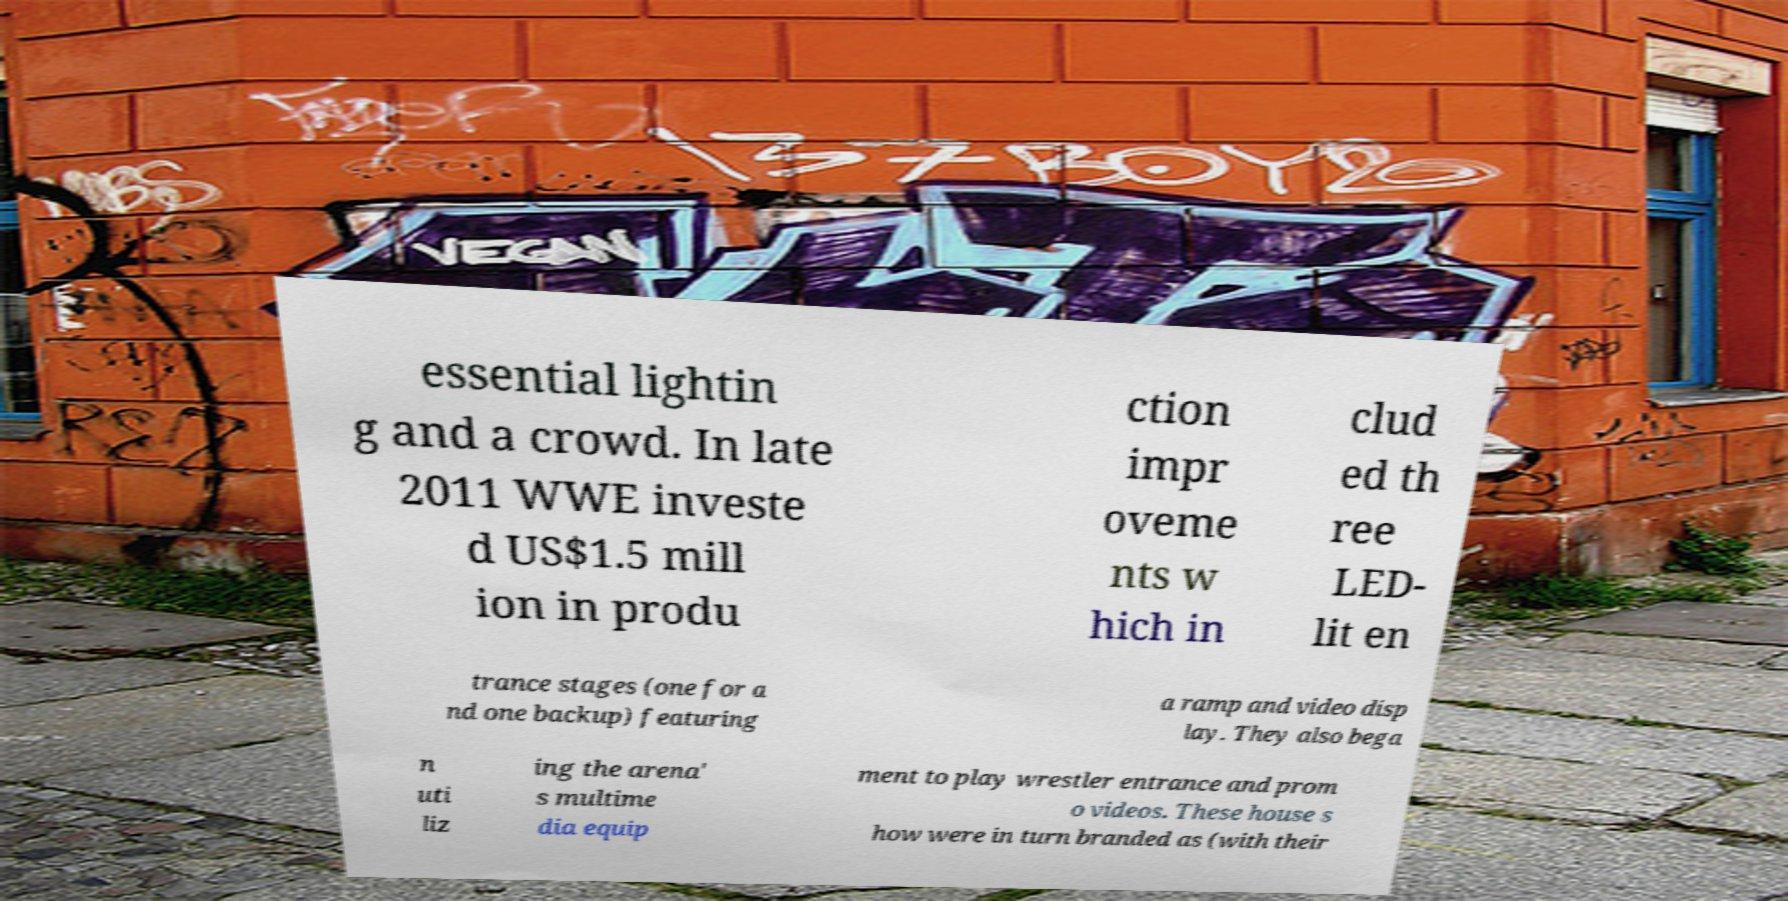For documentation purposes, I need the text within this image transcribed. Could you provide that? essential lightin g and a crowd. In late 2011 WWE investe d US$1.5 mill ion in produ ction impr oveme nts w hich in clud ed th ree LED- lit en trance stages (one for a nd one backup) featuring a ramp and video disp lay. They also bega n uti liz ing the arena' s multime dia equip ment to play wrestler entrance and prom o videos. These house s how were in turn branded as (with their 